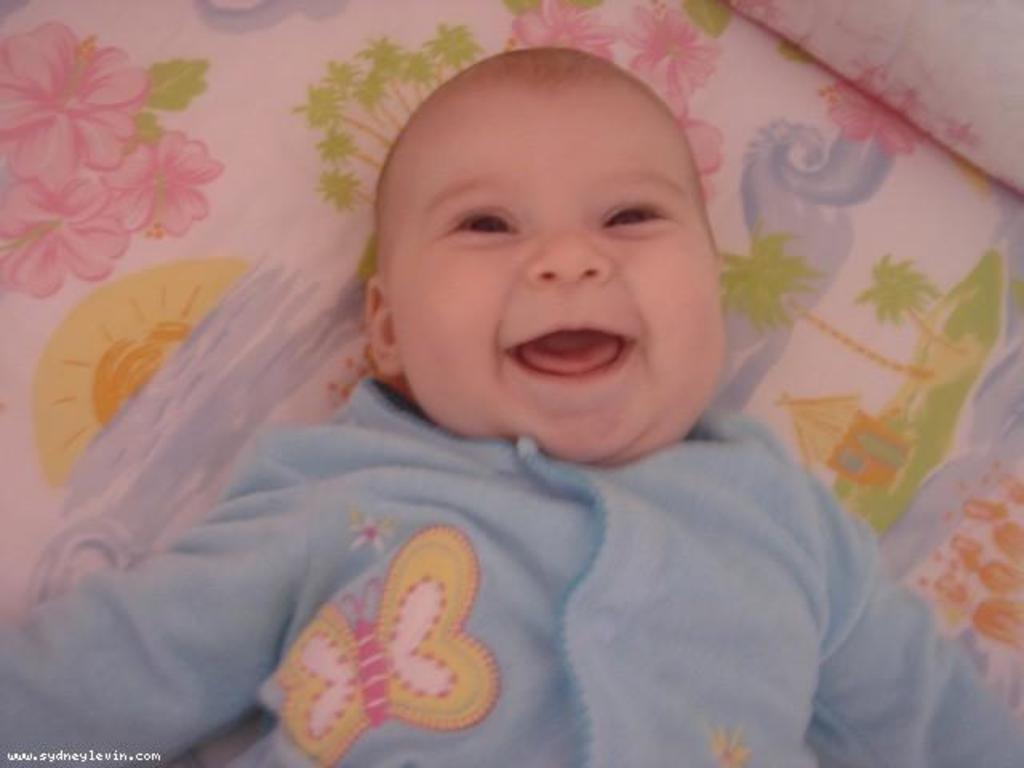What is the main subject of the image? The main subject of the image is a baby. What is the baby wearing? The baby is wearing a blue dress. What is the baby's facial expression? The baby is smiling. Where is the baby located in the image? The baby is lying on a bed. What are the bed's features? The bed has a bed sheet and a pillow. Is there anything else in front of the baby? Yes, there is a watermark in front of the baby. What type of instrument is the baby playing in the image? There is no instrument present in the image; the baby is simply lying on the bed and smiling. Can you tell me how many cacti are visible in the image? There are no cacti present in the image. 